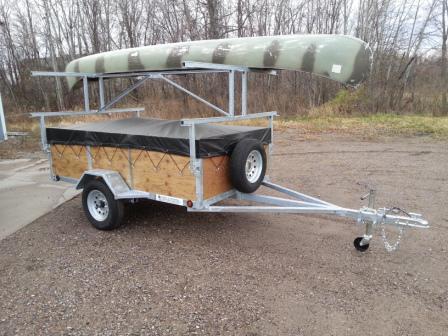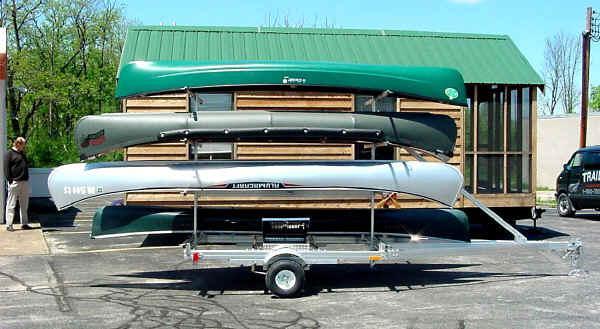The first image is the image on the left, the second image is the image on the right. Considering the images on both sides, is "There are at least four canoes loaded up to be transported elsewhere." valid? Answer yes or no. Yes. The first image is the image on the left, the second image is the image on the right. Assess this claim about the two images: "In one of the pictures, the canoe is attached to the back of a car.". Correct or not? Answer yes or no. No. 